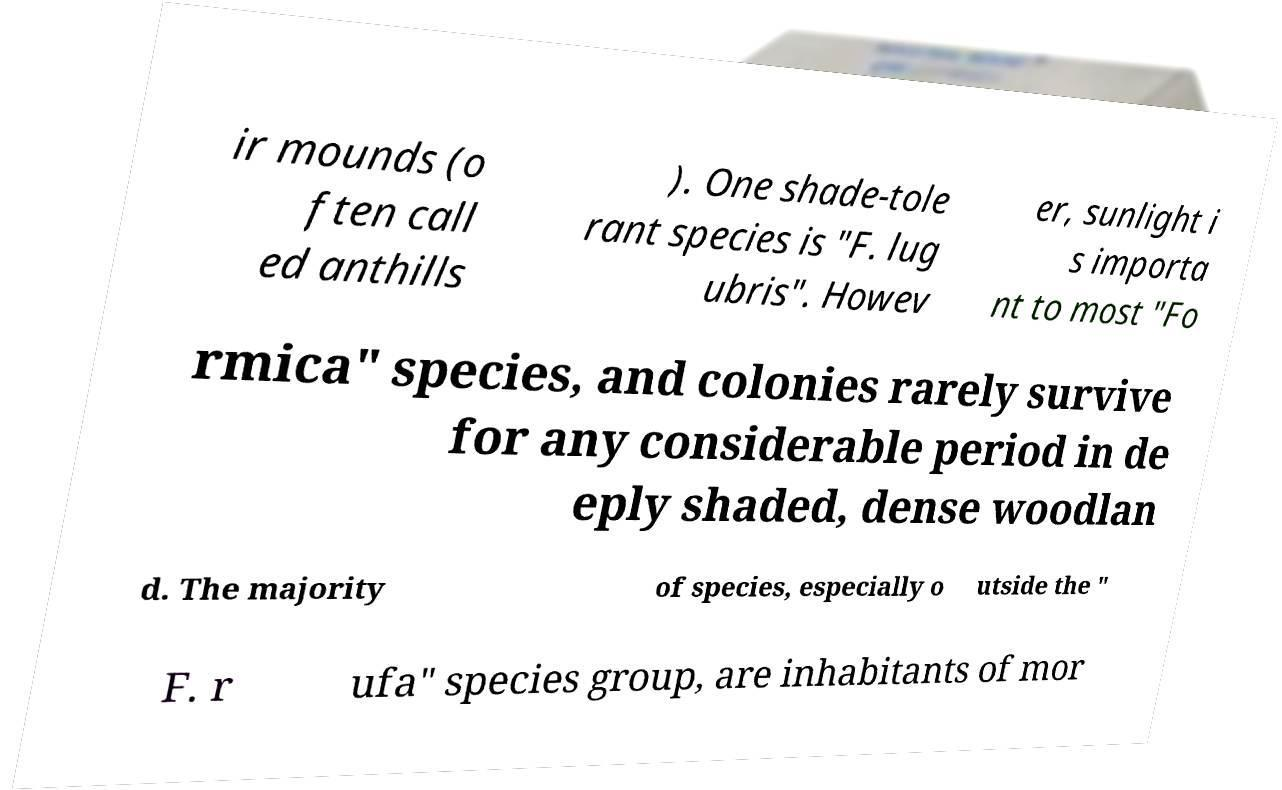Can you read and provide the text displayed in the image?This photo seems to have some interesting text. Can you extract and type it out for me? ir mounds (o ften call ed anthills ). One shade-tole rant species is "F. lug ubris". Howev er, sunlight i s importa nt to most "Fo rmica" species, and colonies rarely survive for any considerable period in de eply shaded, dense woodlan d. The majority of species, especially o utside the " F. r ufa" species group, are inhabitants of mor 